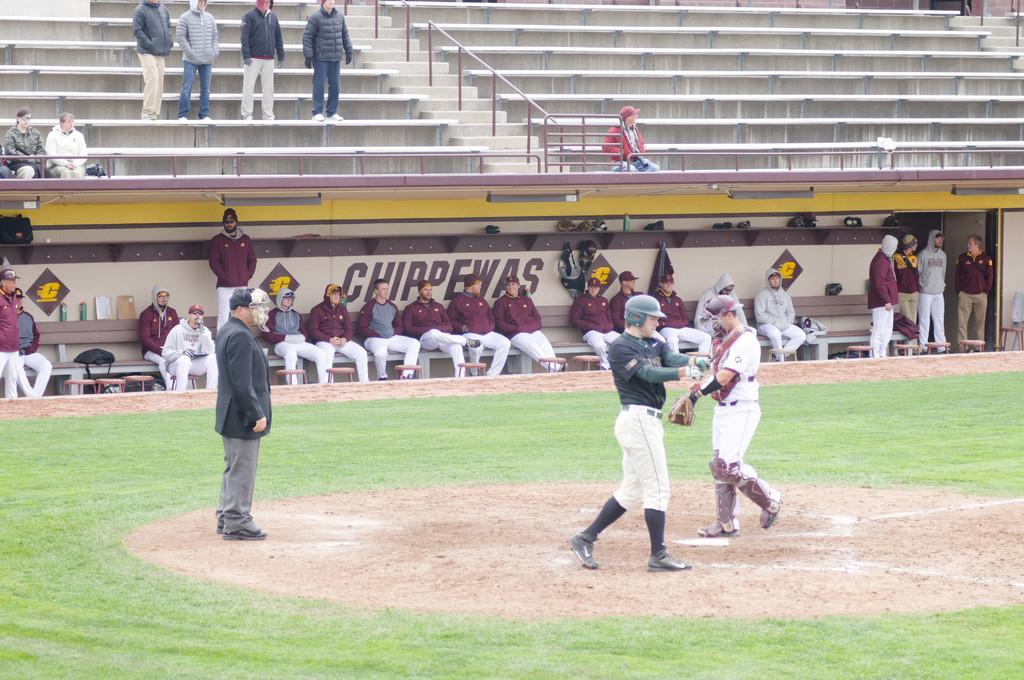<image>
Write a terse but informative summary of the picture. the Chippewas dugout that is near some players 